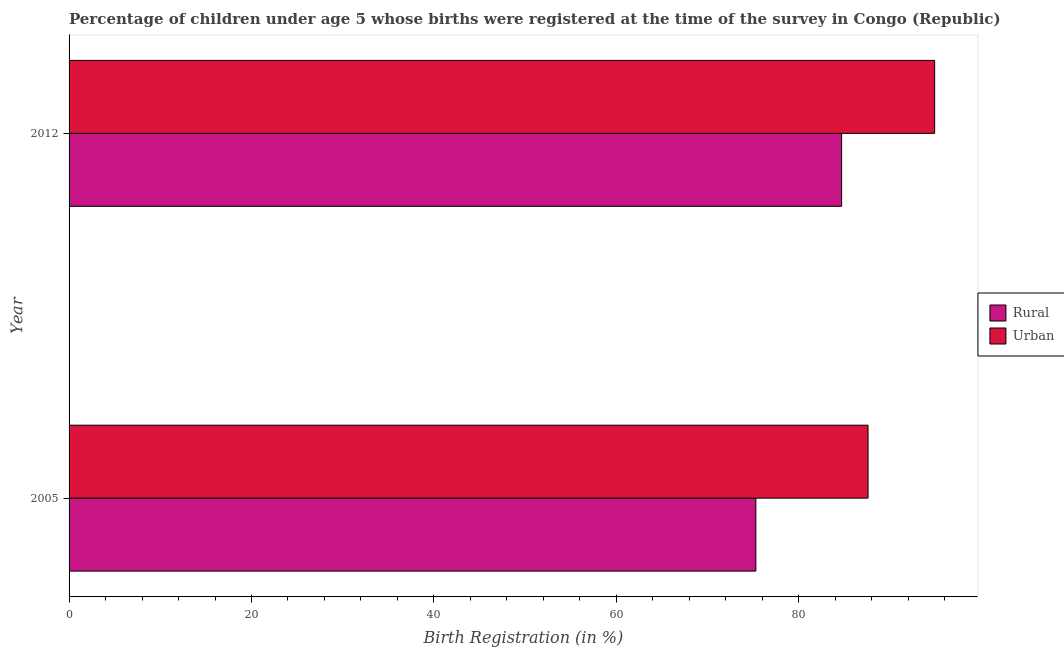How many different coloured bars are there?
Keep it short and to the point. 2. How many groups of bars are there?
Ensure brevity in your answer.  2. Are the number of bars on each tick of the Y-axis equal?
Your response must be concise. Yes. How many bars are there on the 1st tick from the top?
Offer a terse response. 2. How many bars are there on the 2nd tick from the bottom?
Your answer should be compact. 2. In how many cases, is the number of bars for a given year not equal to the number of legend labels?
Offer a terse response. 0. What is the urban birth registration in 2005?
Provide a short and direct response. 87.6. Across all years, what is the maximum urban birth registration?
Make the answer very short. 94.9. Across all years, what is the minimum urban birth registration?
Ensure brevity in your answer.  87.6. What is the total urban birth registration in the graph?
Provide a short and direct response. 182.5. What is the difference between the rural birth registration in 2005 and the urban birth registration in 2012?
Offer a terse response. -19.6. What is the average urban birth registration per year?
Give a very brief answer. 91.25. In how many years, is the urban birth registration greater than 40 %?
Give a very brief answer. 2. What is the ratio of the rural birth registration in 2005 to that in 2012?
Ensure brevity in your answer.  0.89. Is the difference between the rural birth registration in 2005 and 2012 greater than the difference between the urban birth registration in 2005 and 2012?
Ensure brevity in your answer.  No. In how many years, is the urban birth registration greater than the average urban birth registration taken over all years?
Provide a short and direct response. 1. What does the 2nd bar from the top in 2012 represents?
Provide a succinct answer. Rural. What does the 2nd bar from the bottom in 2005 represents?
Your answer should be very brief. Urban. How many bars are there?
Offer a very short reply. 4. How many years are there in the graph?
Your answer should be very brief. 2. What is the difference between two consecutive major ticks on the X-axis?
Ensure brevity in your answer.  20. Does the graph contain any zero values?
Your response must be concise. No. Where does the legend appear in the graph?
Ensure brevity in your answer.  Center right. How many legend labels are there?
Make the answer very short. 2. How are the legend labels stacked?
Ensure brevity in your answer.  Vertical. What is the title of the graph?
Give a very brief answer. Percentage of children under age 5 whose births were registered at the time of the survey in Congo (Republic). Does "Primary education" appear as one of the legend labels in the graph?
Offer a terse response. No. What is the label or title of the X-axis?
Make the answer very short. Birth Registration (in %). What is the Birth Registration (in %) in Rural in 2005?
Offer a very short reply. 75.3. What is the Birth Registration (in %) of Urban in 2005?
Give a very brief answer. 87.6. What is the Birth Registration (in %) in Rural in 2012?
Offer a very short reply. 84.7. What is the Birth Registration (in %) of Urban in 2012?
Keep it short and to the point. 94.9. Across all years, what is the maximum Birth Registration (in %) of Rural?
Your answer should be compact. 84.7. Across all years, what is the maximum Birth Registration (in %) in Urban?
Your answer should be compact. 94.9. Across all years, what is the minimum Birth Registration (in %) of Rural?
Your response must be concise. 75.3. Across all years, what is the minimum Birth Registration (in %) of Urban?
Make the answer very short. 87.6. What is the total Birth Registration (in %) of Rural in the graph?
Provide a short and direct response. 160. What is the total Birth Registration (in %) of Urban in the graph?
Provide a short and direct response. 182.5. What is the difference between the Birth Registration (in %) in Urban in 2005 and that in 2012?
Provide a succinct answer. -7.3. What is the difference between the Birth Registration (in %) in Rural in 2005 and the Birth Registration (in %) in Urban in 2012?
Keep it short and to the point. -19.6. What is the average Birth Registration (in %) of Urban per year?
Offer a terse response. 91.25. In the year 2005, what is the difference between the Birth Registration (in %) in Rural and Birth Registration (in %) in Urban?
Offer a very short reply. -12.3. What is the ratio of the Birth Registration (in %) of Rural in 2005 to that in 2012?
Your response must be concise. 0.89. What is the ratio of the Birth Registration (in %) in Urban in 2005 to that in 2012?
Your answer should be compact. 0.92. 